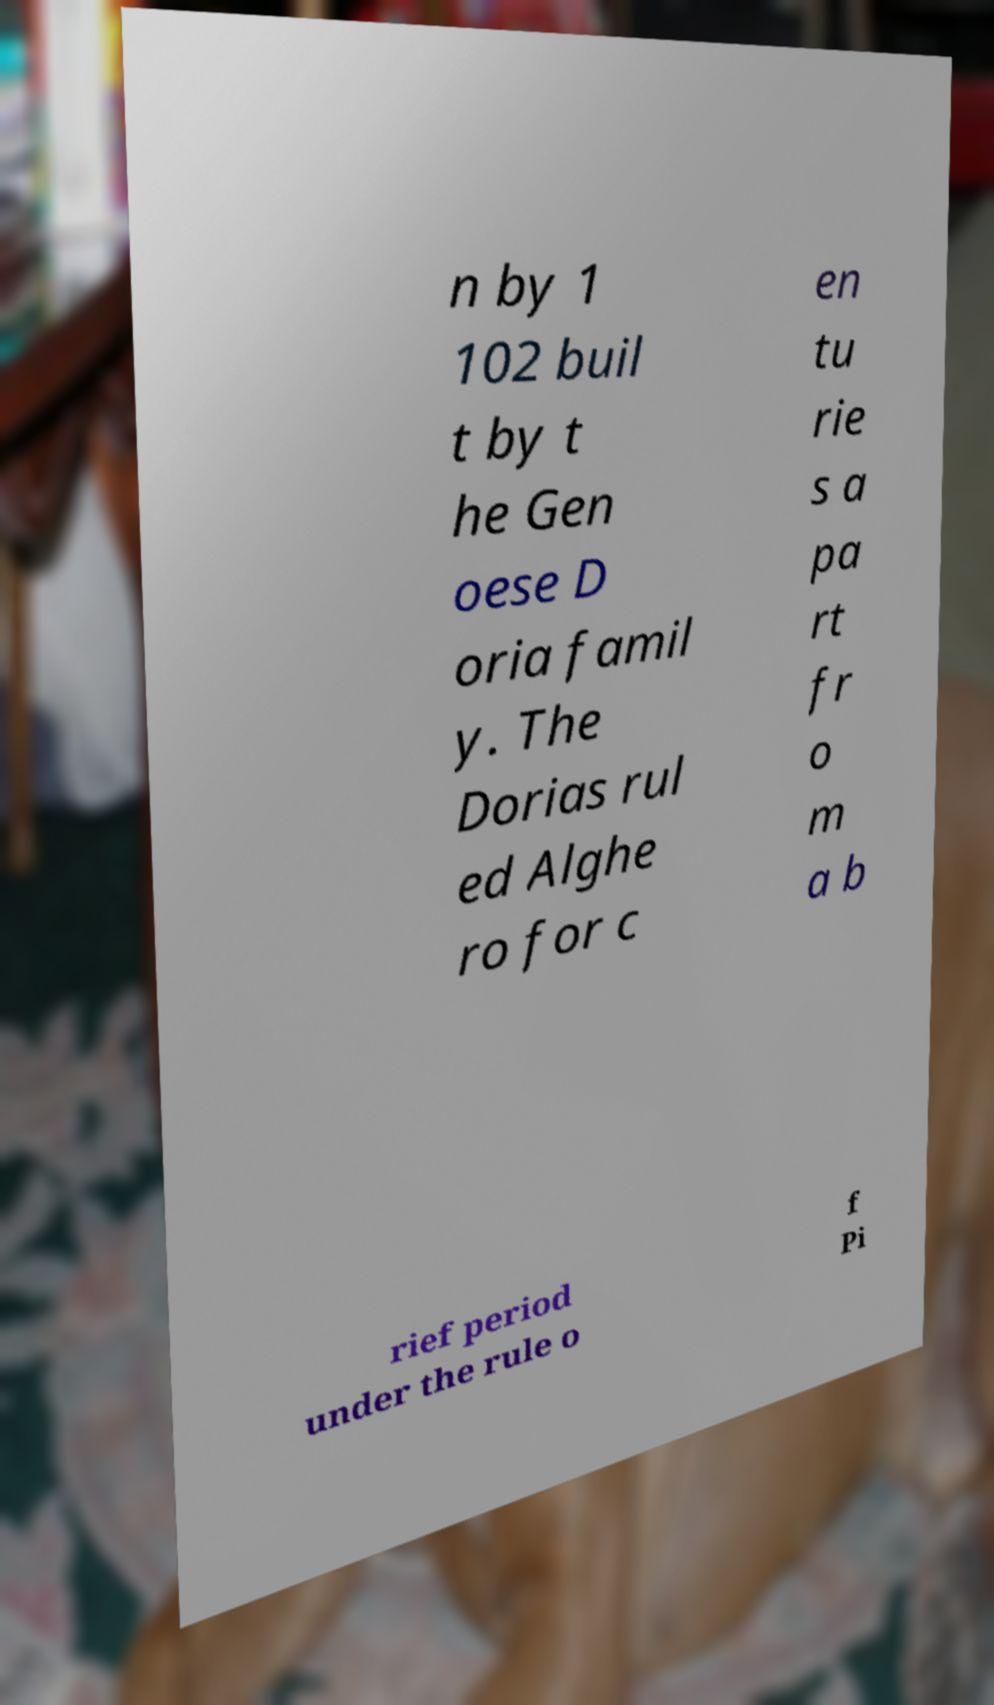Please read and relay the text visible in this image. What does it say? n by 1 102 buil t by t he Gen oese D oria famil y. The Dorias rul ed Alghe ro for c en tu rie s a pa rt fr o m a b rief period under the rule o f Pi 